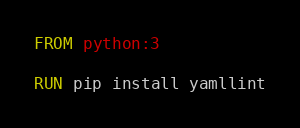<code> <loc_0><loc_0><loc_500><loc_500><_Dockerfile_>FROM python:3

RUN pip install yamllint
</code> 